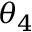<formula> <loc_0><loc_0><loc_500><loc_500>\theta _ { 4 }</formula> 